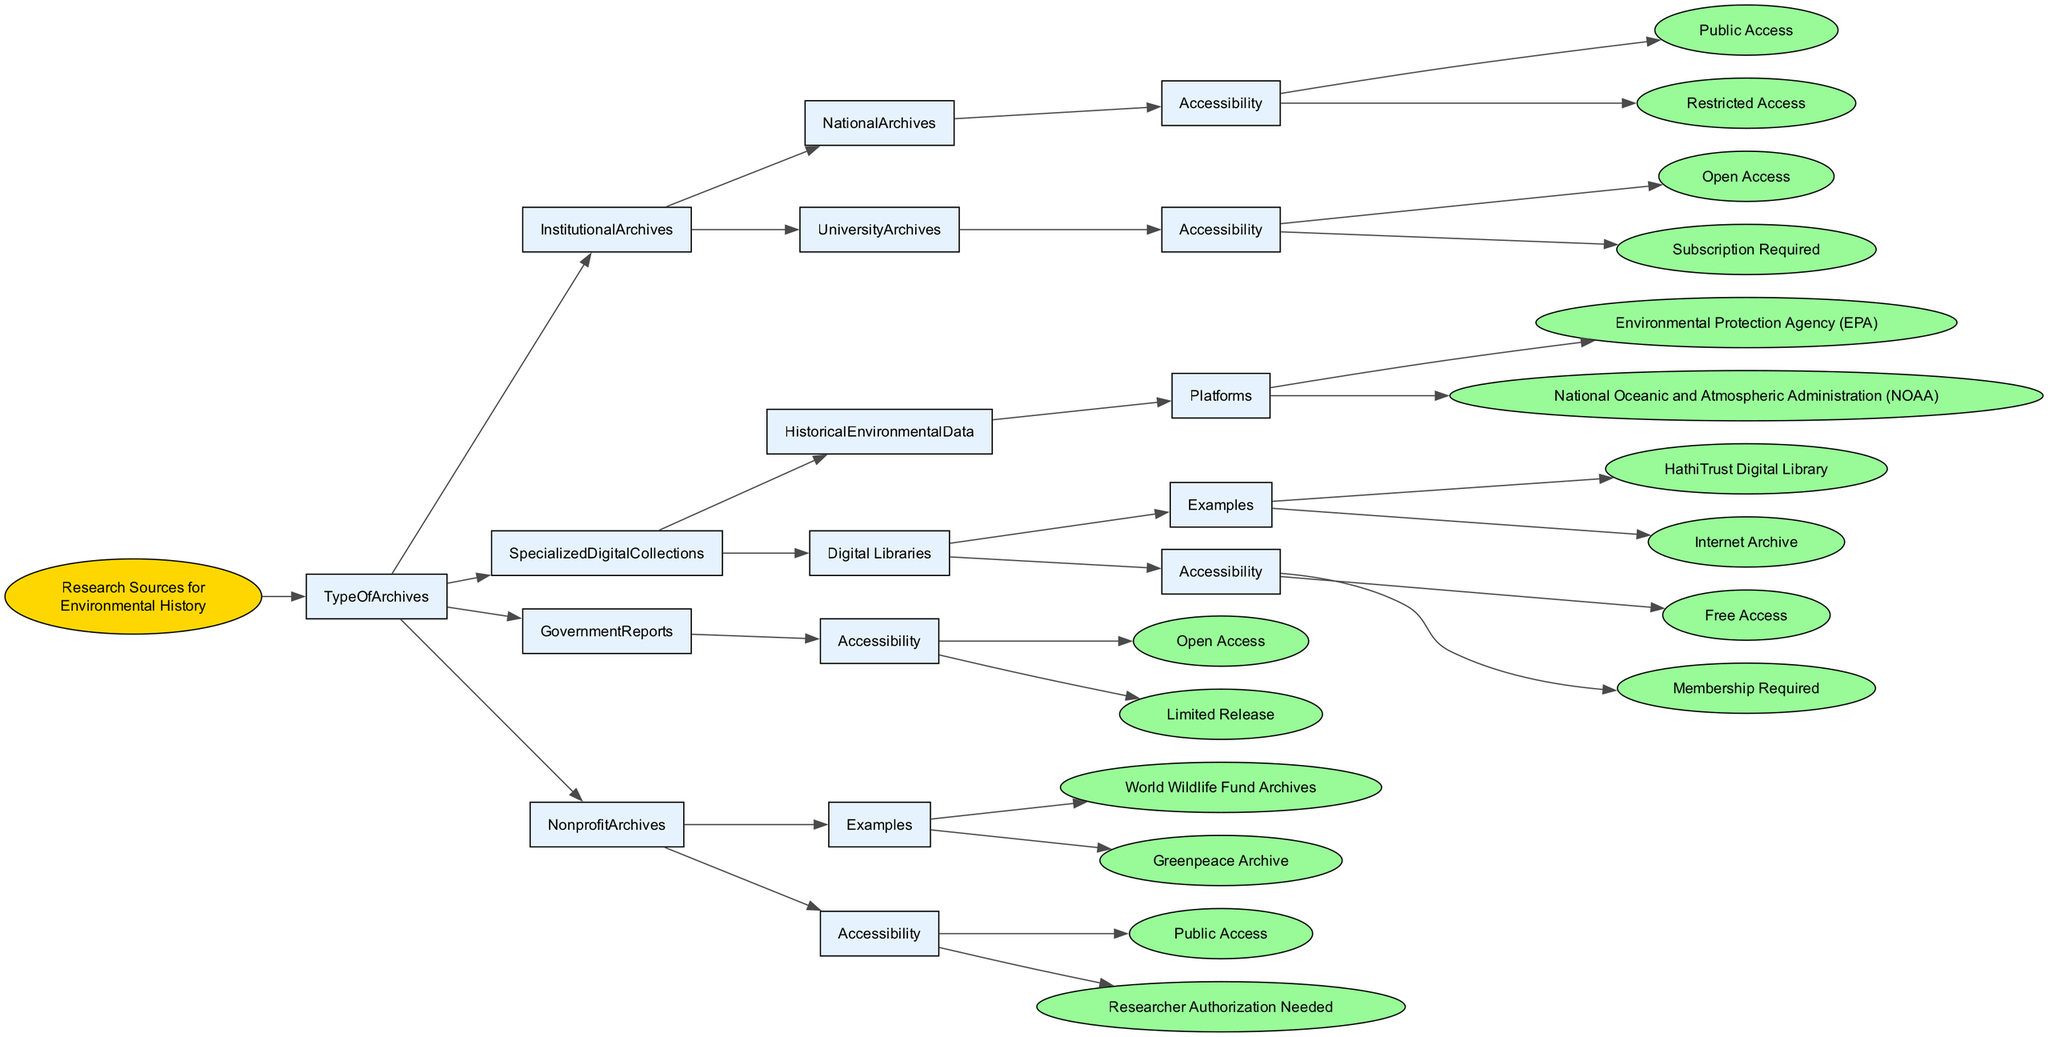What types of archives are categorized under Research Sources for Environmental History? The diagram lists four main types of archives under Research Sources for Environmental History: Institutional Archives, Specialized Digital Collections, Government Reports, and Nonprofit Archives.
Answer: Institutional Archives, Specialized Digital Collections, Government Reports, Nonprofit Archives How many accessibility options are available for University Archives? The diagram shows two accessibility options listed under University Archives: Open Access and Subscription Required. Thus, there are two options available.
Answer: Two Which platforms provide Historical Environmental Data? The diagram specifies that the platforms providing Historical Environmental Data are the Environmental Protection Agency (EPA) and the National Oceanic and Atmospheric Administration (NOAA).
Answer: Environmental Protection Agency (EPA), National Oceanic and Atmospheric Administration (NOAA) Is access to Government Reports open to the public? The diagram indicates that Government Reports are available under Open Access and Limited Release, meaning that at least some reports are available without restrictions, indicating public access.
Answer: Yes What is the relationship between Nonprofit Archives and their accessibility? The diagram shows that Nonprofit Archives have examples like World Wildlife Fund Archives and Greenpeace Archive, and their accessibility can be either Public Access or Researcher Authorization Needed. This means their accessibility options are directly associated with the archives themselves.
Answer: Examples of Nonprofit Archives are linked to Public Access or Researcher Authorization Needed What type of access is required for Digital Libraries in the Specialized Digital Collections? The diagram reveals that Digital Libraries, such as HathiTrust Digital Library and Internet Archive, have accessibility categorized under Free Access and Membership Required. Thus, one may need either no fee or must become a member to access content.
Answer: Free Access, Membership Required Which specific archives require researcher authorization for access? According to the diagram, Nonprofit Archives such as World Wildlife Fund Archives and Greenpeace Archive require Researcher Authorization Needed for access, indicating that not all materials are publicly available.
Answer: Researcher Authorization Needed Name one example of National Archives categorized under Institutional Archives. The diagram identifies National Archives as a type under Institutional Archives, but does not specify an example. Therefore, the answer refers back to National Archives itself.
Answer: National Archives 